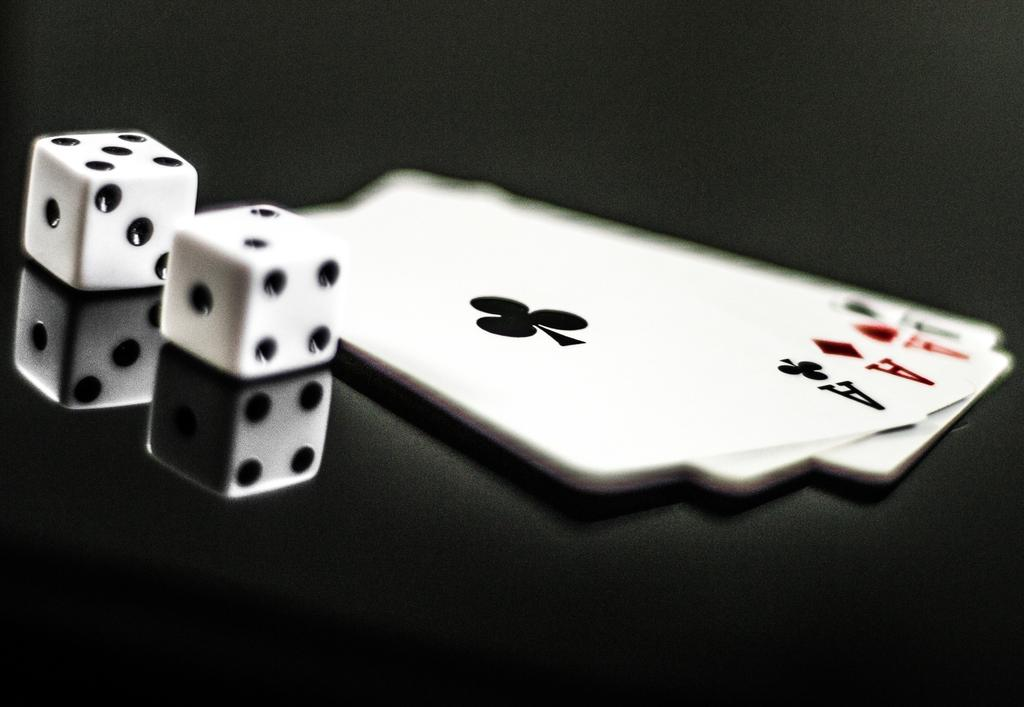What objects are present in the image that resemble cubes? There are cubes in the image. What other items can be seen in the image? There are playing cards on the right side of the image. What type of stitch is used to connect the cubes in the image? There is no stitching present in the image, as the cubes are not connected by any thread or material. In which direction are the playing cards facing in the image? The direction in which the playing cards are facing cannot be determined from the image alone, as the image does not provide a clear view of the card faces. 